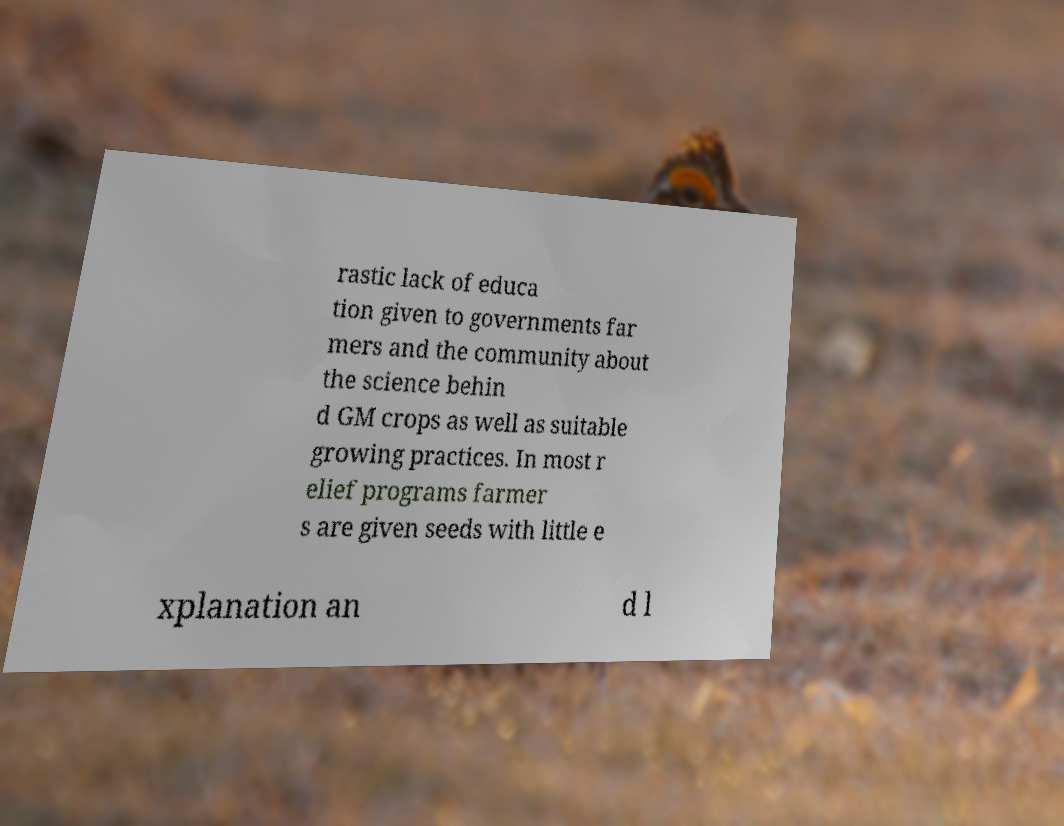Please read and relay the text visible in this image. What does it say? rastic lack of educa tion given to governments far mers and the community about the science behin d GM crops as well as suitable growing practices. In most r elief programs farmer s are given seeds with little e xplanation an d l 